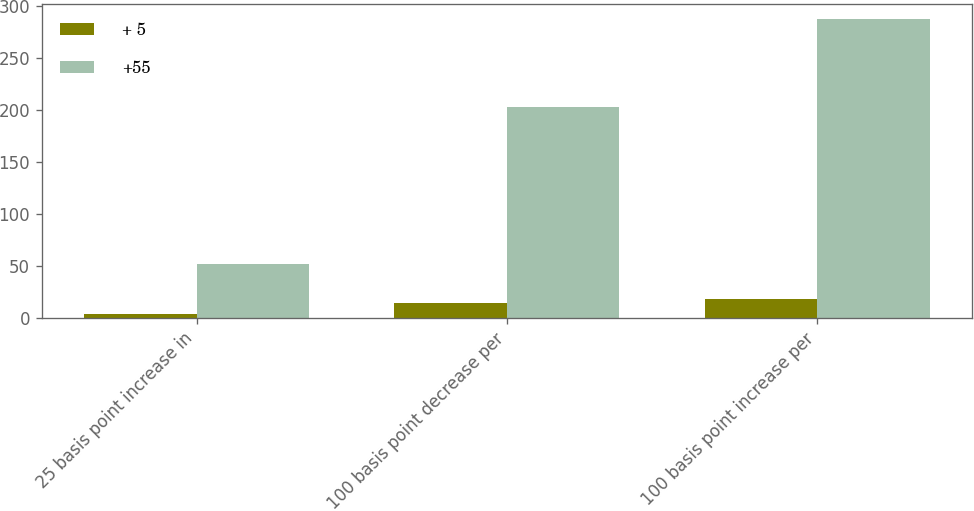Convert chart. <chart><loc_0><loc_0><loc_500><loc_500><stacked_bar_chart><ecel><fcel>25 basis point increase in<fcel>100 basis point decrease per<fcel>100 basis point increase per<nl><fcel>+ 5<fcel>4<fcel>14<fcel>18<nl><fcel>+55<fcel>52<fcel>203<fcel>287<nl></chart> 